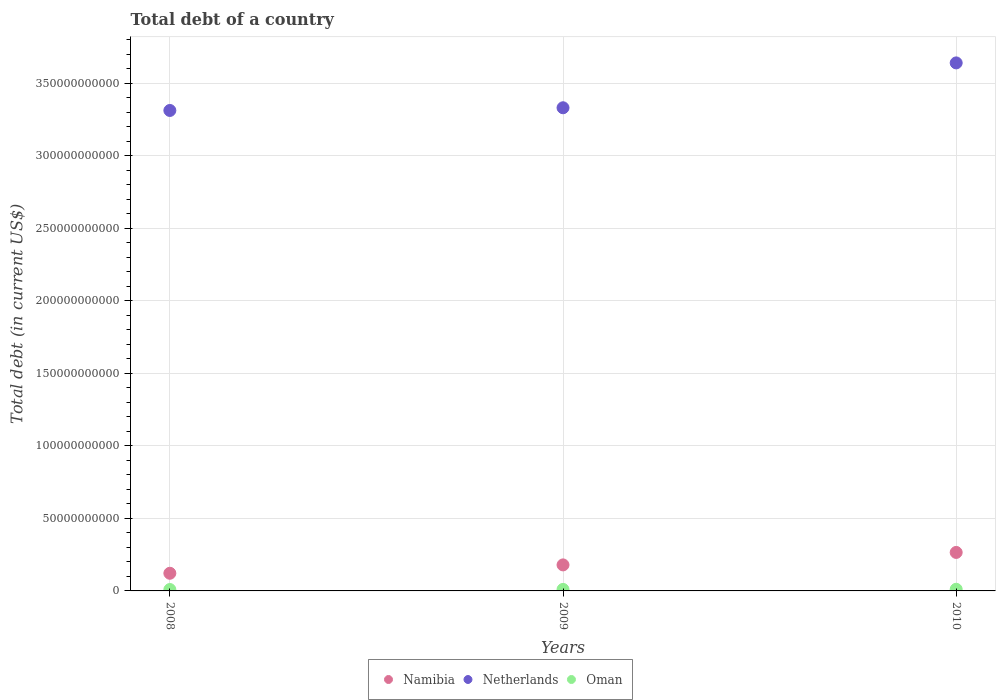Is the number of dotlines equal to the number of legend labels?
Your answer should be very brief. Yes. What is the debt in Namibia in 2009?
Your answer should be compact. 1.79e+1. Across all years, what is the maximum debt in Netherlands?
Your answer should be compact. 3.64e+11. Across all years, what is the minimum debt in Netherlands?
Offer a very short reply. 3.31e+11. In which year was the debt in Netherlands maximum?
Provide a short and direct response. 2010. What is the total debt in Namibia in the graph?
Keep it short and to the point. 5.67e+1. What is the difference between the debt in Netherlands in 2008 and that in 2010?
Ensure brevity in your answer.  -3.28e+1. What is the difference between the debt in Netherlands in 2008 and the debt in Namibia in 2010?
Ensure brevity in your answer.  3.05e+11. What is the average debt in Namibia per year?
Your answer should be compact. 1.89e+1. In the year 2010, what is the difference between the debt in Netherlands and debt in Namibia?
Provide a short and direct response. 3.38e+11. What is the ratio of the debt in Netherlands in 2008 to that in 2010?
Your answer should be compact. 0.91. Is the difference between the debt in Netherlands in 2008 and 2010 greater than the difference between the debt in Namibia in 2008 and 2010?
Make the answer very short. No. What is the difference between the highest and the second highest debt in Oman?
Your answer should be very brief. 9.14e+07. What is the difference between the highest and the lowest debt in Netherlands?
Your response must be concise. 3.28e+1. In how many years, is the debt in Oman greater than the average debt in Oman taken over all years?
Keep it short and to the point. 1. Is the sum of the debt in Netherlands in 2008 and 2009 greater than the maximum debt in Namibia across all years?
Give a very brief answer. Yes. Is it the case that in every year, the sum of the debt in Netherlands and debt in Oman  is greater than the debt in Namibia?
Offer a terse response. Yes. Does the debt in Oman monotonically increase over the years?
Provide a short and direct response. Yes. How many dotlines are there?
Provide a succinct answer. 3. What is the difference between two consecutive major ticks on the Y-axis?
Offer a very short reply. 5.00e+1. Where does the legend appear in the graph?
Give a very brief answer. Bottom center. What is the title of the graph?
Make the answer very short. Total debt of a country. Does "Jamaica" appear as one of the legend labels in the graph?
Give a very brief answer. No. What is the label or title of the Y-axis?
Your response must be concise. Total debt (in current US$). What is the Total debt (in current US$) in Namibia in 2008?
Ensure brevity in your answer.  1.22e+1. What is the Total debt (in current US$) of Netherlands in 2008?
Give a very brief answer. 3.31e+11. What is the Total debt (in current US$) of Oman in 2008?
Keep it short and to the point. 9.65e+08. What is the Total debt (in current US$) of Namibia in 2009?
Your answer should be very brief. 1.79e+1. What is the Total debt (in current US$) in Netherlands in 2009?
Provide a succinct answer. 3.33e+11. What is the Total debt (in current US$) of Oman in 2009?
Give a very brief answer. 1.04e+09. What is the Total debt (in current US$) in Namibia in 2010?
Your answer should be very brief. 2.65e+1. What is the Total debt (in current US$) of Netherlands in 2010?
Offer a very short reply. 3.64e+11. What is the Total debt (in current US$) of Oman in 2010?
Make the answer very short. 1.14e+09. Across all years, what is the maximum Total debt (in current US$) of Namibia?
Offer a very short reply. 2.65e+1. Across all years, what is the maximum Total debt (in current US$) in Netherlands?
Make the answer very short. 3.64e+11. Across all years, what is the maximum Total debt (in current US$) in Oman?
Keep it short and to the point. 1.14e+09. Across all years, what is the minimum Total debt (in current US$) in Namibia?
Offer a terse response. 1.22e+1. Across all years, what is the minimum Total debt (in current US$) in Netherlands?
Offer a very short reply. 3.31e+11. Across all years, what is the minimum Total debt (in current US$) in Oman?
Keep it short and to the point. 9.65e+08. What is the total Total debt (in current US$) in Namibia in the graph?
Provide a short and direct response. 5.67e+1. What is the total Total debt (in current US$) of Netherlands in the graph?
Offer a very short reply. 1.03e+12. What is the total Total debt (in current US$) of Oman in the graph?
Your answer should be very brief. 3.15e+09. What is the difference between the Total debt (in current US$) of Namibia in 2008 and that in 2009?
Offer a very short reply. -5.77e+09. What is the difference between the Total debt (in current US$) of Netherlands in 2008 and that in 2009?
Your answer should be very brief. -1.86e+09. What is the difference between the Total debt (in current US$) of Oman in 2008 and that in 2009?
Ensure brevity in your answer.  -8.00e+07. What is the difference between the Total debt (in current US$) of Namibia in 2008 and that in 2010?
Offer a terse response. -1.44e+1. What is the difference between the Total debt (in current US$) in Netherlands in 2008 and that in 2010?
Offer a very short reply. -3.28e+1. What is the difference between the Total debt (in current US$) in Oman in 2008 and that in 2010?
Provide a short and direct response. -1.71e+08. What is the difference between the Total debt (in current US$) of Namibia in 2009 and that in 2010?
Keep it short and to the point. -8.60e+09. What is the difference between the Total debt (in current US$) in Netherlands in 2009 and that in 2010?
Offer a very short reply. -3.09e+1. What is the difference between the Total debt (in current US$) in Oman in 2009 and that in 2010?
Your answer should be compact. -9.14e+07. What is the difference between the Total debt (in current US$) in Namibia in 2008 and the Total debt (in current US$) in Netherlands in 2009?
Your response must be concise. -3.21e+11. What is the difference between the Total debt (in current US$) of Namibia in 2008 and the Total debt (in current US$) of Oman in 2009?
Your answer should be very brief. 1.11e+1. What is the difference between the Total debt (in current US$) in Netherlands in 2008 and the Total debt (in current US$) in Oman in 2009?
Provide a short and direct response. 3.30e+11. What is the difference between the Total debt (in current US$) of Namibia in 2008 and the Total debt (in current US$) of Netherlands in 2010?
Your answer should be very brief. -3.52e+11. What is the difference between the Total debt (in current US$) of Namibia in 2008 and the Total debt (in current US$) of Oman in 2010?
Your answer should be very brief. 1.10e+1. What is the difference between the Total debt (in current US$) in Netherlands in 2008 and the Total debt (in current US$) in Oman in 2010?
Give a very brief answer. 3.30e+11. What is the difference between the Total debt (in current US$) of Namibia in 2009 and the Total debt (in current US$) of Netherlands in 2010?
Your response must be concise. -3.46e+11. What is the difference between the Total debt (in current US$) in Namibia in 2009 and the Total debt (in current US$) in Oman in 2010?
Provide a short and direct response. 1.68e+1. What is the difference between the Total debt (in current US$) in Netherlands in 2009 and the Total debt (in current US$) in Oman in 2010?
Keep it short and to the point. 3.32e+11. What is the average Total debt (in current US$) of Namibia per year?
Your response must be concise. 1.89e+1. What is the average Total debt (in current US$) of Netherlands per year?
Your response must be concise. 3.43e+11. What is the average Total debt (in current US$) of Oman per year?
Offer a very short reply. 1.05e+09. In the year 2008, what is the difference between the Total debt (in current US$) of Namibia and Total debt (in current US$) of Netherlands?
Your answer should be compact. -3.19e+11. In the year 2008, what is the difference between the Total debt (in current US$) of Namibia and Total debt (in current US$) of Oman?
Give a very brief answer. 1.12e+1. In the year 2008, what is the difference between the Total debt (in current US$) of Netherlands and Total debt (in current US$) of Oman?
Offer a very short reply. 3.30e+11. In the year 2009, what is the difference between the Total debt (in current US$) in Namibia and Total debt (in current US$) in Netherlands?
Provide a succinct answer. -3.15e+11. In the year 2009, what is the difference between the Total debt (in current US$) of Namibia and Total debt (in current US$) of Oman?
Offer a very short reply. 1.69e+1. In the year 2009, what is the difference between the Total debt (in current US$) of Netherlands and Total debt (in current US$) of Oman?
Offer a very short reply. 3.32e+11. In the year 2010, what is the difference between the Total debt (in current US$) of Namibia and Total debt (in current US$) of Netherlands?
Offer a terse response. -3.38e+11. In the year 2010, what is the difference between the Total debt (in current US$) in Namibia and Total debt (in current US$) in Oman?
Your response must be concise. 2.54e+1. In the year 2010, what is the difference between the Total debt (in current US$) in Netherlands and Total debt (in current US$) in Oman?
Your response must be concise. 3.63e+11. What is the ratio of the Total debt (in current US$) in Namibia in 2008 to that in 2009?
Your response must be concise. 0.68. What is the ratio of the Total debt (in current US$) of Oman in 2008 to that in 2009?
Your response must be concise. 0.92. What is the ratio of the Total debt (in current US$) of Namibia in 2008 to that in 2010?
Your response must be concise. 0.46. What is the ratio of the Total debt (in current US$) in Netherlands in 2008 to that in 2010?
Offer a terse response. 0.91. What is the ratio of the Total debt (in current US$) of Oman in 2008 to that in 2010?
Offer a very short reply. 0.85. What is the ratio of the Total debt (in current US$) in Namibia in 2009 to that in 2010?
Ensure brevity in your answer.  0.68. What is the ratio of the Total debt (in current US$) of Netherlands in 2009 to that in 2010?
Offer a terse response. 0.92. What is the ratio of the Total debt (in current US$) of Oman in 2009 to that in 2010?
Your answer should be compact. 0.92. What is the difference between the highest and the second highest Total debt (in current US$) in Namibia?
Your response must be concise. 8.60e+09. What is the difference between the highest and the second highest Total debt (in current US$) of Netherlands?
Make the answer very short. 3.09e+1. What is the difference between the highest and the second highest Total debt (in current US$) in Oman?
Keep it short and to the point. 9.14e+07. What is the difference between the highest and the lowest Total debt (in current US$) in Namibia?
Your answer should be very brief. 1.44e+1. What is the difference between the highest and the lowest Total debt (in current US$) of Netherlands?
Provide a succinct answer. 3.28e+1. What is the difference between the highest and the lowest Total debt (in current US$) of Oman?
Your response must be concise. 1.71e+08. 